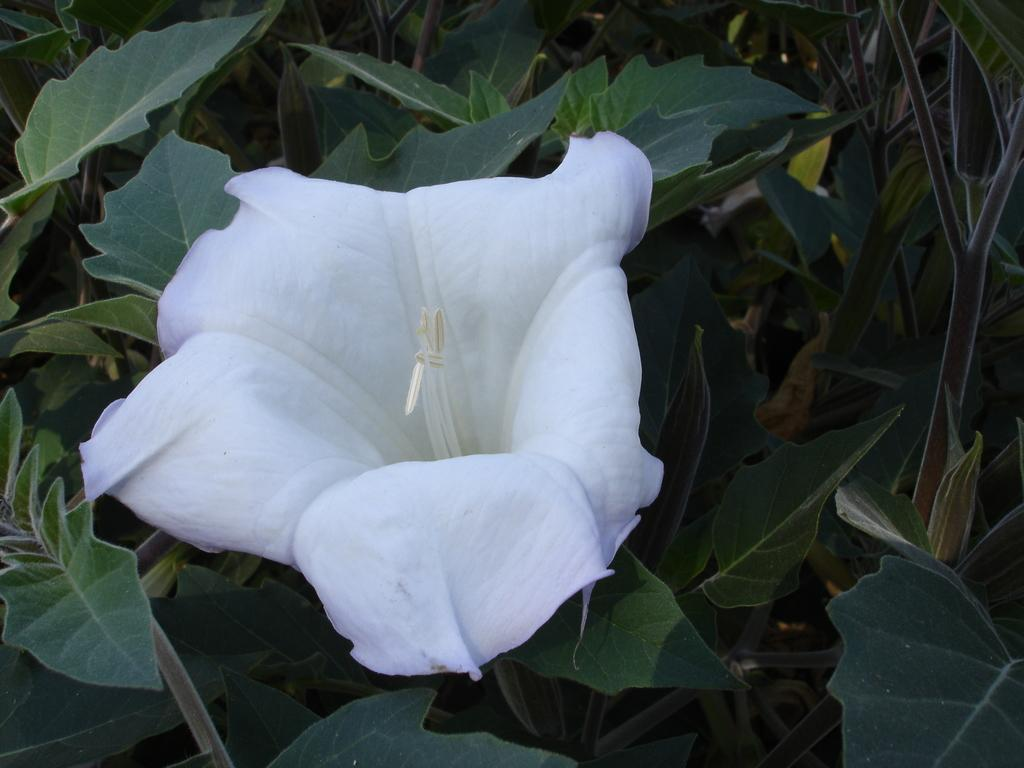What is the primary subject of the image? The primary subject of the image is plants. Can you describe any specific features of the plants? There is a flower on one of the plants. What type of hat is the plant wearing in the image? There is no hat present on the plant in the image. 